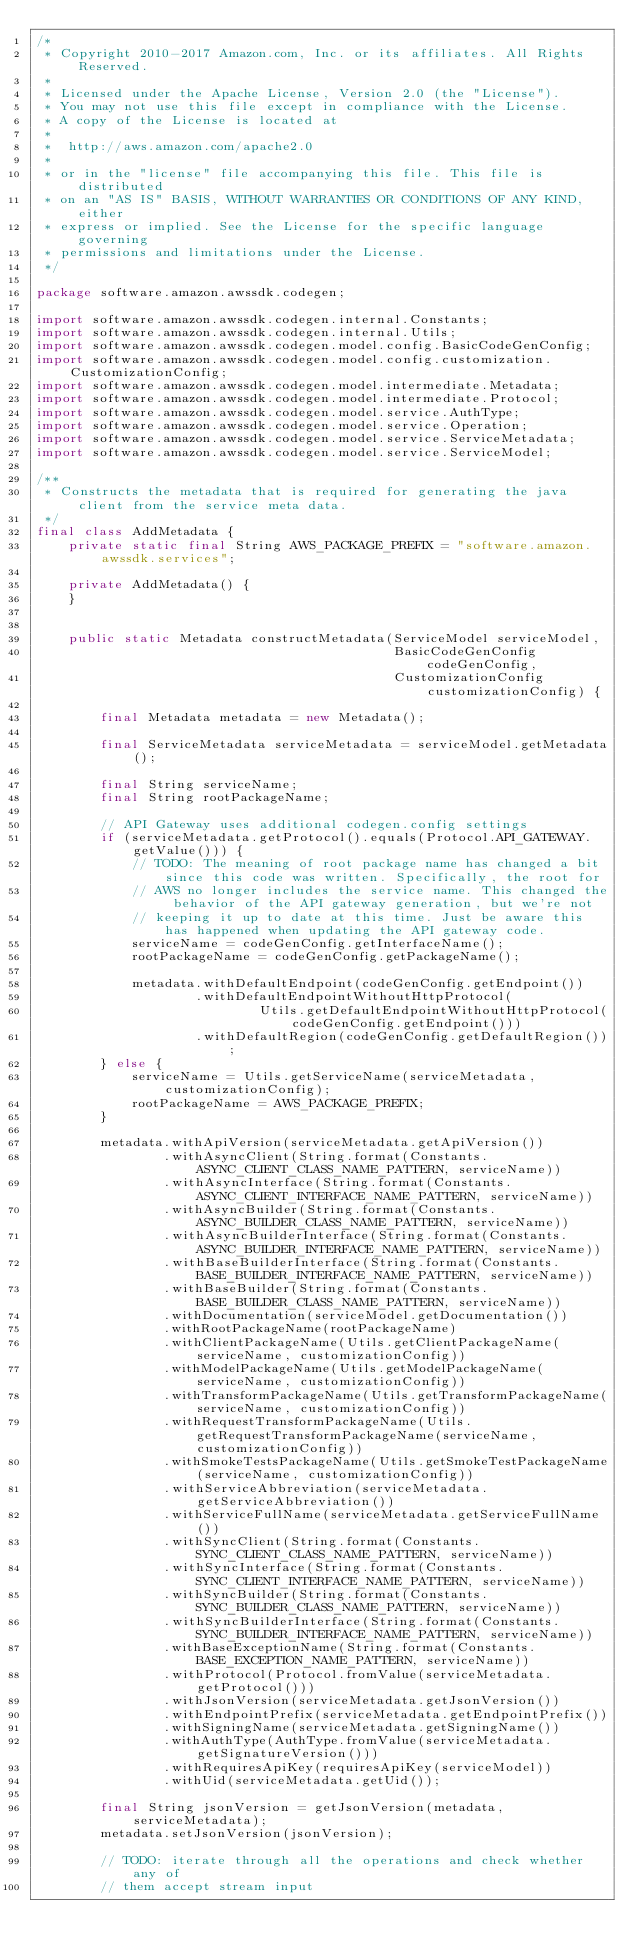<code> <loc_0><loc_0><loc_500><loc_500><_Java_>/*
 * Copyright 2010-2017 Amazon.com, Inc. or its affiliates. All Rights Reserved.
 *
 * Licensed under the Apache License, Version 2.0 (the "License").
 * You may not use this file except in compliance with the License.
 * A copy of the License is located at
 *
 *  http://aws.amazon.com/apache2.0
 *
 * or in the "license" file accompanying this file. This file is distributed
 * on an "AS IS" BASIS, WITHOUT WARRANTIES OR CONDITIONS OF ANY KIND, either
 * express or implied. See the License for the specific language governing
 * permissions and limitations under the License.
 */

package software.amazon.awssdk.codegen;

import software.amazon.awssdk.codegen.internal.Constants;
import software.amazon.awssdk.codegen.internal.Utils;
import software.amazon.awssdk.codegen.model.config.BasicCodeGenConfig;
import software.amazon.awssdk.codegen.model.config.customization.CustomizationConfig;
import software.amazon.awssdk.codegen.model.intermediate.Metadata;
import software.amazon.awssdk.codegen.model.intermediate.Protocol;
import software.amazon.awssdk.codegen.model.service.AuthType;
import software.amazon.awssdk.codegen.model.service.Operation;
import software.amazon.awssdk.codegen.model.service.ServiceMetadata;
import software.amazon.awssdk.codegen.model.service.ServiceModel;

/**
 * Constructs the metadata that is required for generating the java client from the service meta data.
 */
final class AddMetadata {
    private static final String AWS_PACKAGE_PREFIX = "software.amazon.awssdk.services";

    private AddMetadata() {
    }


    public static Metadata constructMetadata(ServiceModel serviceModel,
                                             BasicCodeGenConfig codeGenConfig,
                                             CustomizationConfig customizationConfig) {

        final Metadata metadata = new Metadata();

        final ServiceMetadata serviceMetadata = serviceModel.getMetadata();

        final String serviceName;
        final String rootPackageName;

        // API Gateway uses additional codegen.config settings
        if (serviceMetadata.getProtocol().equals(Protocol.API_GATEWAY.getValue())) {
            // TODO: The meaning of root package name has changed a bit since this code was written. Specifically, the root for
            // AWS no longer includes the service name. This changed the behavior of the API gateway generation, but we're not
            // keeping it up to date at this time. Just be aware this has happened when updating the API gateway code.
            serviceName = codeGenConfig.getInterfaceName();
            rootPackageName = codeGenConfig.getPackageName();

            metadata.withDefaultEndpoint(codeGenConfig.getEndpoint())
                    .withDefaultEndpointWithoutHttpProtocol(
                            Utils.getDefaultEndpointWithoutHttpProtocol(codeGenConfig.getEndpoint()))
                    .withDefaultRegion(codeGenConfig.getDefaultRegion());
        } else {
            serviceName = Utils.getServiceName(serviceMetadata, customizationConfig);
            rootPackageName = AWS_PACKAGE_PREFIX;
        }

        metadata.withApiVersion(serviceMetadata.getApiVersion())
                .withAsyncClient(String.format(Constants.ASYNC_CLIENT_CLASS_NAME_PATTERN, serviceName))
                .withAsyncInterface(String.format(Constants.ASYNC_CLIENT_INTERFACE_NAME_PATTERN, serviceName))
                .withAsyncBuilder(String.format(Constants.ASYNC_BUILDER_CLASS_NAME_PATTERN, serviceName))
                .withAsyncBuilderInterface(String.format(Constants.ASYNC_BUILDER_INTERFACE_NAME_PATTERN, serviceName))
                .withBaseBuilderInterface(String.format(Constants.BASE_BUILDER_INTERFACE_NAME_PATTERN, serviceName))
                .withBaseBuilder(String.format(Constants.BASE_BUILDER_CLASS_NAME_PATTERN, serviceName))
                .withDocumentation(serviceModel.getDocumentation())
                .withRootPackageName(rootPackageName)
                .withClientPackageName(Utils.getClientPackageName(serviceName, customizationConfig))
                .withModelPackageName(Utils.getModelPackageName(serviceName, customizationConfig))
                .withTransformPackageName(Utils.getTransformPackageName(serviceName, customizationConfig))
                .withRequestTransformPackageName(Utils.getRequestTransformPackageName(serviceName, customizationConfig))
                .withSmokeTestsPackageName(Utils.getSmokeTestPackageName(serviceName, customizationConfig))
                .withServiceAbbreviation(serviceMetadata.getServiceAbbreviation())
                .withServiceFullName(serviceMetadata.getServiceFullName())
                .withSyncClient(String.format(Constants.SYNC_CLIENT_CLASS_NAME_PATTERN, serviceName))
                .withSyncInterface(String.format(Constants.SYNC_CLIENT_INTERFACE_NAME_PATTERN, serviceName))
                .withSyncBuilder(String.format(Constants.SYNC_BUILDER_CLASS_NAME_PATTERN, serviceName))
                .withSyncBuilderInterface(String.format(Constants.SYNC_BUILDER_INTERFACE_NAME_PATTERN, serviceName))
                .withBaseExceptionName(String.format(Constants.BASE_EXCEPTION_NAME_PATTERN, serviceName))
                .withProtocol(Protocol.fromValue(serviceMetadata.getProtocol()))
                .withJsonVersion(serviceMetadata.getJsonVersion())
                .withEndpointPrefix(serviceMetadata.getEndpointPrefix())
                .withSigningName(serviceMetadata.getSigningName())
                .withAuthType(AuthType.fromValue(serviceMetadata.getSignatureVersion()))
                .withRequiresApiKey(requiresApiKey(serviceModel))
                .withUid(serviceMetadata.getUid());

        final String jsonVersion = getJsonVersion(metadata, serviceMetadata);
        metadata.setJsonVersion(jsonVersion);

        // TODO: iterate through all the operations and check whether any of
        // them accept stream input</code> 